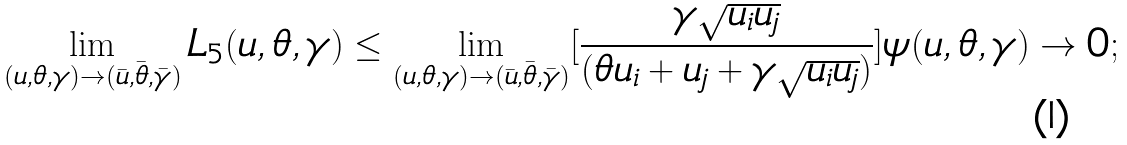Convert formula to latex. <formula><loc_0><loc_0><loc_500><loc_500>\lim _ { ( u , \theta , \gamma ) \to ( \bar { u } , \bar { \theta } , \bar { \gamma } ) } L _ { 5 } ( u , \theta , \gamma ) \leq \lim _ { ( u , \theta , \gamma ) \to ( \bar { u } , \bar { \theta } , \bar { \gamma } ) } [ \frac { \gamma \sqrt { u _ { i } u _ { j } } } { ( \theta u _ { i } + u _ { j } + \gamma \sqrt { u _ { i } u _ { j } } ) } ] \psi ( u , \theta , \gamma ) \to 0 ;</formula> 